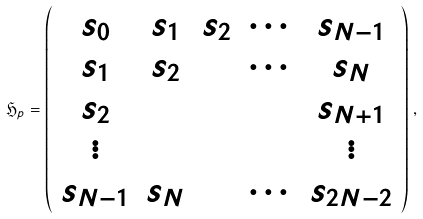Convert formula to latex. <formula><loc_0><loc_0><loc_500><loc_500>\mathfrak { H } _ { p } = \left ( \begin{array} { c c c c c } s _ { 0 } & s _ { 1 } & s _ { 2 } & \cdots & s _ { N - 1 } \\ s _ { 1 } & s _ { 2 } & & \cdots & s _ { N } \\ s _ { 2 } & & & & s _ { N + 1 } \\ \vdots & & & & \vdots \\ s _ { N - 1 } & s _ { N } & & \cdots & s _ { 2 N - 2 } \end{array} \right ) \, ,</formula> 